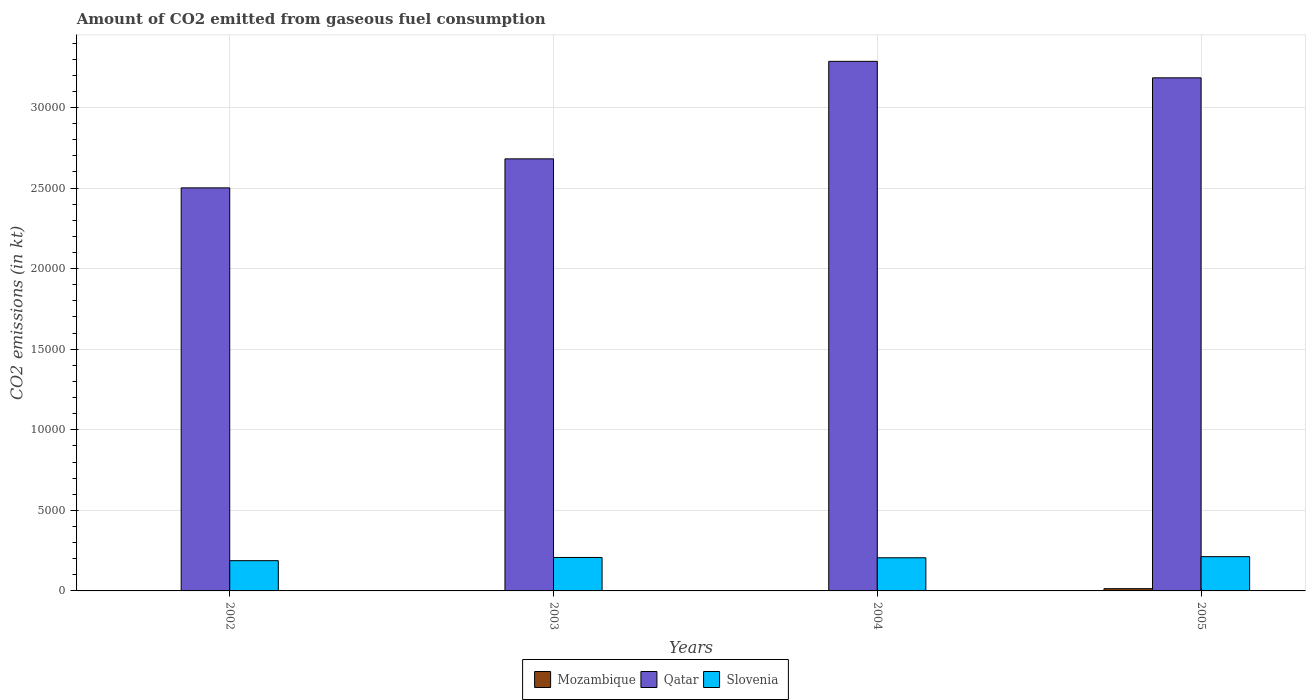How many different coloured bars are there?
Provide a short and direct response. 3. How many bars are there on the 2nd tick from the left?
Offer a very short reply. 3. How many bars are there on the 4th tick from the right?
Provide a short and direct response. 3. What is the amount of CO2 emitted in Mozambique in 2002?
Your answer should be compact. 3.67. Across all years, what is the maximum amount of CO2 emitted in Qatar?
Offer a terse response. 3.29e+04. Across all years, what is the minimum amount of CO2 emitted in Qatar?
Your response must be concise. 2.50e+04. What is the total amount of CO2 emitted in Mozambique in the graph?
Offer a terse response. 154.01. What is the difference between the amount of CO2 emitted in Mozambique in 2003 and that in 2005?
Give a very brief answer. -135.68. What is the difference between the amount of CO2 emitted in Slovenia in 2002 and the amount of CO2 emitted in Mozambique in 2004?
Offer a very short reply. 1870.17. What is the average amount of CO2 emitted in Slovenia per year?
Your answer should be very brief. 2034.27. In the year 2005, what is the difference between the amount of CO2 emitted in Slovenia and amount of CO2 emitted in Qatar?
Give a very brief answer. -2.97e+04. In how many years, is the amount of CO2 emitted in Qatar greater than 10000 kt?
Your response must be concise. 4. What is the ratio of the amount of CO2 emitted in Mozambique in 2004 to that in 2005?
Your answer should be very brief. 0.05. Is the difference between the amount of CO2 emitted in Slovenia in 2004 and 2005 greater than the difference between the amount of CO2 emitted in Qatar in 2004 and 2005?
Keep it short and to the point. No. What is the difference between the highest and the second highest amount of CO2 emitted in Slovenia?
Provide a succinct answer. 51.34. What is the difference between the highest and the lowest amount of CO2 emitted in Slovenia?
Provide a succinct answer. 249.36. In how many years, is the amount of CO2 emitted in Mozambique greater than the average amount of CO2 emitted in Mozambique taken over all years?
Keep it short and to the point. 1. Is the sum of the amount of CO2 emitted in Slovenia in 2002 and 2003 greater than the maximum amount of CO2 emitted in Qatar across all years?
Ensure brevity in your answer.  No. What does the 3rd bar from the left in 2004 represents?
Provide a short and direct response. Slovenia. What does the 1st bar from the right in 2004 represents?
Keep it short and to the point. Slovenia. What is the difference between two consecutive major ticks on the Y-axis?
Provide a succinct answer. 5000. Does the graph contain any zero values?
Give a very brief answer. No. Does the graph contain grids?
Ensure brevity in your answer.  Yes. Where does the legend appear in the graph?
Offer a very short reply. Bottom center. How many legend labels are there?
Keep it short and to the point. 3. What is the title of the graph?
Keep it short and to the point. Amount of CO2 emitted from gaseous fuel consumption. What is the label or title of the X-axis?
Give a very brief answer. Years. What is the label or title of the Y-axis?
Offer a very short reply. CO2 emissions (in kt). What is the CO2 emissions (in kt) of Mozambique in 2002?
Your response must be concise. 3.67. What is the CO2 emissions (in kt) of Qatar in 2002?
Your answer should be very brief. 2.50e+04. What is the CO2 emissions (in kt) of Slovenia in 2002?
Provide a succinct answer. 1877.5. What is the CO2 emissions (in kt) of Mozambique in 2003?
Offer a terse response. 3.67. What is the CO2 emissions (in kt) in Qatar in 2003?
Provide a short and direct response. 2.68e+04. What is the CO2 emissions (in kt) of Slovenia in 2003?
Make the answer very short. 2075.52. What is the CO2 emissions (in kt) in Mozambique in 2004?
Your response must be concise. 7.33. What is the CO2 emissions (in kt) of Qatar in 2004?
Offer a terse response. 3.29e+04. What is the CO2 emissions (in kt) in Slovenia in 2004?
Your response must be concise. 2057.19. What is the CO2 emissions (in kt) of Mozambique in 2005?
Provide a short and direct response. 139.35. What is the CO2 emissions (in kt) in Qatar in 2005?
Offer a very short reply. 3.18e+04. What is the CO2 emissions (in kt) of Slovenia in 2005?
Your response must be concise. 2126.86. Across all years, what is the maximum CO2 emissions (in kt) in Mozambique?
Your answer should be compact. 139.35. Across all years, what is the maximum CO2 emissions (in kt) of Qatar?
Make the answer very short. 3.29e+04. Across all years, what is the maximum CO2 emissions (in kt) in Slovenia?
Provide a short and direct response. 2126.86. Across all years, what is the minimum CO2 emissions (in kt) in Mozambique?
Your answer should be very brief. 3.67. Across all years, what is the minimum CO2 emissions (in kt) in Qatar?
Provide a short and direct response. 2.50e+04. Across all years, what is the minimum CO2 emissions (in kt) of Slovenia?
Ensure brevity in your answer.  1877.5. What is the total CO2 emissions (in kt) in Mozambique in the graph?
Your answer should be compact. 154.01. What is the total CO2 emissions (in kt) of Qatar in the graph?
Give a very brief answer. 1.17e+05. What is the total CO2 emissions (in kt) of Slovenia in the graph?
Your response must be concise. 8137.07. What is the difference between the CO2 emissions (in kt) in Qatar in 2002 and that in 2003?
Provide a short and direct response. -1800.5. What is the difference between the CO2 emissions (in kt) of Slovenia in 2002 and that in 2003?
Provide a short and direct response. -198.02. What is the difference between the CO2 emissions (in kt) of Mozambique in 2002 and that in 2004?
Give a very brief answer. -3.67. What is the difference between the CO2 emissions (in kt) in Qatar in 2002 and that in 2004?
Give a very brief answer. -7851.05. What is the difference between the CO2 emissions (in kt) of Slovenia in 2002 and that in 2004?
Your response must be concise. -179.68. What is the difference between the CO2 emissions (in kt) of Mozambique in 2002 and that in 2005?
Ensure brevity in your answer.  -135.68. What is the difference between the CO2 emissions (in kt) in Qatar in 2002 and that in 2005?
Ensure brevity in your answer.  -6827.95. What is the difference between the CO2 emissions (in kt) of Slovenia in 2002 and that in 2005?
Give a very brief answer. -249.36. What is the difference between the CO2 emissions (in kt) of Mozambique in 2003 and that in 2004?
Give a very brief answer. -3.67. What is the difference between the CO2 emissions (in kt) of Qatar in 2003 and that in 2004?
Provide a short and direct response. -6050.55. What is the difference between the CO2 emissions (in kt) of Slovenia in 2003 and that in 2004?
Provide a succinct answer. 18.34. What is the difference between the CO2 emissions (in kt) in Mozambique in 2003 and that in 2005?
Make the answer very short. -135.68. What is the difference between the CO2 emissions (in kt) of Qatar in 2003 and that in 2005?
Your response must be concise. -5027.46. What is the difference between the CO2 emissions (in kt) in Slovenia in 2003 and that in 2005?
Provide a short and direct response. -51.34. What is the difference between the CO2 emissions (in kt) of Mozambique in 2004 and that in 2005?
Give a very brief answer. -132.01. What is the difference between the CO2 emissions (in kt) of Qatar in 2004 and that in 2005?
Ensure brevity in your answer.  1023.09. What is the difference between the CO2 emissions (in kt) of Slovenia in 2004 and that in 2005?
Offer a terse response. -69.67. What is the difference between the CO2 emissions (in kt) in Mozambique in 2002 and the CO2 emissions (in kt) in Qatar in 2003?
Make the answer very short. -2.68e+04. What is the difference between the CO2 emissions (in kt) in Mozambique in 2002 and the CO2 emissions (in kt) in Slovenia in 2003?
Your response must be concise. -2071.86. What is the difference between the CO2 emissions (in kt) of Qatar in 2002 and the CO2 emissions (in kt) of Slovenia in 2003?
Offer a very short reply. 2.29e+04. What is the difference between the CO2 emissions (in kt) of Mozambique in 2002 and the CO2 emissions (in kt) of Qatar in 2004?
Provide a short and direct response. -3.29e+04. What is the difference between the CO2 emissions (in kt) of Mozambique in 2002 and the CO2 emissions (in kt) of Slovenia in 2004?
Ensure brevity in your answer.  -2053.52. What is the difference between the CO2 emissions (in kt) in Qatar in 2002 and the CO2 emissions (in kt) in Slovenia in 2004?
Your answer should be very brief. 2.30e+04. What is the difference between the CO2 emissions (in kt) of Mozambique in 2002 and the CO2 emissions (in kt) of Qatar in 2005?
Ensure brevity in your answer.  -3.18e+04. What is the difference between the CO2 emissions (in kt) in Mozambique in 2002 and the CO2 emissions (in kt) in Slovenia in 2005?
Your answer should be compact. -2123.19. What is the difference between the CO2 emissions (in kt) in Qatar in 2002 and the CO2 emissions (in kt) in Slovenia in 2005?
Your answer should be compact. 2.29e+04. What is the difference between the CO2 emissions (in kt) in Mozambique in 2003 and the CO2 emissions (in kt) in Qatar in 2004?
Keep it short and to the point. -3.29e+04. What is the difference between the CO2 emissions (in kt) of Mozambique in 2003 and the CO2 emissions (in kt) of Slovenia in 2004?
Offer a terse response. -2053.52. What is the difference between the CO2 emissions (in kt) of Qatar in 2003 and the CO2 emissions (in kt) of Slovenia in 2004?
Make the answer very short. 2.48e+04. What is the difference between the CO2 emissions (in kt) in Mozambique in 2003 and the CO2 emissions (in kt) in Qatar in 2005?
Provide a succinct answer. -3.18e+04. What is the difference between the CO2 emissions (in kt) of Mozambique in 2003 and the CO2 emissions (in kt) of Slovenia in 2005?
Offer a very short reply. -2123.19. What is the difference between the CO2 emissions (in kt) in Qatar in 2003 and the CO2 emissions (in kt) in Slovenia in 2005?
Your answer should be very brief. 2.47e+04. What is the difference between the CO2 emissions (in kt) in Mozambique in 2004 and the CO2 emissions (in kt) in Qatar in 2005?
Ensure brevity in your answer.  -3.18e+04. What is the difference between the CO2 emissions (in kt) in Mozambique in 2004 and the CO2 emissions (in kt) in Slovenia in 2005?
Your answer should be very brief. -2119.53. What is the difference between the CO2 emissions (in kt) of Qatar in 2004 and the CO2 emissions (in kt) of Slovenia in 2005?
Give a very brief answer. 3.07e+04. What is the average CO2 emissions (in kt) in Mozambique per year?
Ensure brevity in your answer.  38.5. What is the average CO2 emissions (in kt) of Qatar per year?
Make the answer very short. 2.91e+04. What is the average CO2 emissions (in kt) of Slovenia per year?
Keep it short and to the point. 2034.27. In the year 2002, what is the difference between the CO2 emissions (in kt) of Mozambique and CO2 emissions (in kt) of Qatar?
Keep it short and to the point. -2.50e+04. In the year 2002, what is the difference between the CO2 emissions (in kt) in Mozambique and CO2 emissions (in kt) in Slovenia?
Provide a succinct answer. -1873.84. In the year 2002, what is the difference between the CO2 emissions (in kt) in Qatar and CO2 emissions (in kt) in Slovenia?
Make the answer very short. 2.31e+04. In the year 2003, what is the difference between the CO2 emissions (in kt) in Mozambique and CO2 emissions (in kt) in Qatar?
Ensure brevity in your answer.  -2.68e+04. In the year 2003, what is the difference between the CO2 emissions (in kt) of Mozambique and CO2 emissions (in kt) of Slovenia?
Offer a very short reply. -2071.86. In the year 2003, what is the difference between the CO2 emissions (in kt) of Qatar and CO2 emissions (in kt) of Slovenia?
Keep it short and to the point. 2.47e+04. In the year 2004, what is the difference between the CO2 emissions (in kt) in Mozambique and CO2 emissions (in kt) in Qatar?
Your response must be concise. -3.29e+04. In the year 2004, what is the difference between the CO2 emissions (in kt) of Mozambique and CO2 emissions (in kt) of Slovenia?
Give a very brief answer. -2049.85. In the year 2004, what is the difference between the CO2 emissions (in kt) of Qatar and CO2 emissions (in kt) of Slovenia?
Offer a very short reply. 3.08e+04. In the year 2005, what is the difference between the CO2 emissions (in kt) of Mozambique and CO2 emissions (in kt) of Qatar?
Give a very brief answer. -3.17e+04. In the year 2005, what is the difference between the CO2 emissions (in kt) of Mozambique and CO2 emissions (in kt) of Slovenia?
Offer a terse response. -1987.51. In the year 2005, what is the difference between the CO2 emissions (in kt) in Qatar and CO2 emissions (in kt) in Slovenia?
Provide a succinct answer. 2.97e+04. What is the ratio of the CO2 emissions (in kt) of Qatar in 2002 to that in 2003?
Make the answer very short. 0.93. What is the ratio of the CO2 emissions (in kt) of Slovenia in 2002 to that in 2003?
Offer a very short reply. 0.9. What is the ratio of the CO2 emissions (in kt) in Qatar in 2002 to that in 2004?
Your response must be concise. 0.76. What is the ratio of the CO2 emissions (in kt) in Slovenia in 2002 to that in 2004?
Your answer should be compact. 0.91. What is the ratio of the CO2 emissions (in kt) in Mozambique in 2002 to that in 2005?
Your answer should be compact. 0.03. What is the ratio of the CO2 emissions (in kt) in Qatar in 2002 to that in 2005?
Give a very brief answer. 0.79. What is the ratio of the CO2 emissions (in kt) of Slovenia in 2002 to that in 2005?
Give a very brief answer. 0.88. What is the ratio of the CO2 emissions (in kt) in Qatar in 2003 to that in 2004?
Give a very brief answer. 0.82. What is the ratio of the CO2 emissions (in kt) of Slovenia in 2003 to that in 2004?
Your response must be concise. 1.01. What is the ratio of the CO2 emissions (in kt) of Mozambique in 2003 to that in 2005?
Provide a succinct answer. 0.03. What is the ratio of the CO2 emissions (in kt) in Qatar in 2003 to that in 2005?
Offer a terse response. 0.84. What is the ratio of the CO2 emissions (in kt) of Slovenia in 2003 to that in 2005?
Make the answer very short. 0.98. What is the ratio of the CO2 emissions (in kt) in Mozambique in 2004 to that in 2005?
Your response must be concise. 0.05. What is the ratio of the CO2 emissions (in kt) in Qatar in 2004 to that in 2005?
Offer a very short reply. 1.03. What is the ratio of the CO2 emissions (in kt) of Slovenia in 2004 to that in 2005?
Give a very brief answer. 0.97. What is the difference between the highest and the second highest CO2 emissions (in kt) of Mozambique?
Your answer should be very brief. 132.01. What is the difference between the highest and the second highest CO2 emissions (in kt) in Qatar?
Make the answer very short. 1023.09. What is the difference between the highest and the second highest CO2 emissions (in kt) of Slovenia?
Provide a succinct answer. 51.34. What is the difference between the highest and the lowest CO2 emissions (in kt) of Mozambique?
Keep it short and to the point. 135.68. What is the difference between the highest and the lowest CO2 emissions (in kt) in Qatar?
Give a very brief answer. 7851.05. What is the difference between the highest and the lowest CO2 emissions (in kt) of Slovenia?
Ensure brevity in your answer.  249.36. 